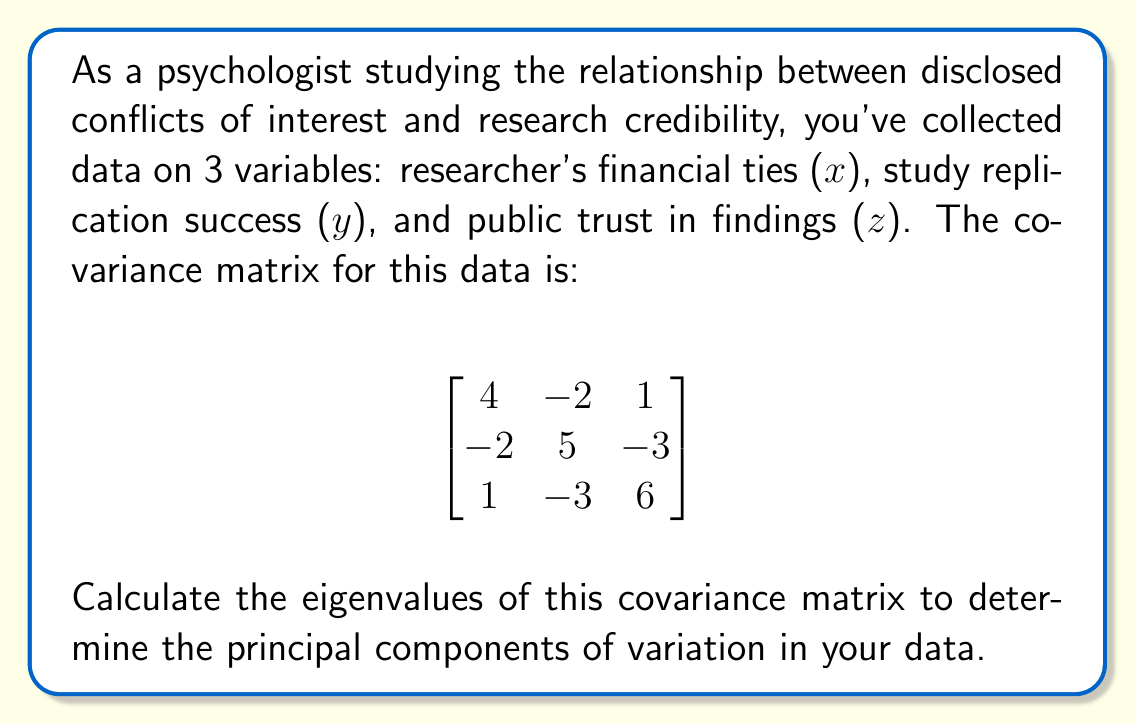Show me your answer to this math problem. To find the eigenvalues of the covariance matrix, we need to solve the characteristic equation:

$$\det(A - \lambda I) = 0$$

Where $A$ is our covariance matrix and $\lambda$ represents the eigenvalues.

1) First, let's set up the equation:

$$\det\begin{pmatrix}
4-\lambda & -2 & 1 \\
-2 & 5-\lambda & -3 \\
1 & -3 & 6-\lambda
\end{pmatrix} = 0$$

2) Expanding the determinant:

$$(4-\lambda)[(5-\lambda)(6-\lambda) - 9] + (-2)[(-2)(6-\lambda) - 1] + (1)[(-2)(-3) - (5-\lambda)] = 0$$

3) Simplifying:

$$(4-\lambda)(30-11\lambda+\lambda^2-9) + (-2)(-12+2\lambda-1) + (1)(6-5+\lambda) = 0$$
$$(4-\lambda)(21-11\lambda+\lambda^2) + (-2)(-13+2\lambda) + (1+\lambda) = 0$$

4) Expanding:

$$84-44\lambda+4\lambda^2-21\lambda+11\lambda^2-\lambda^3 + 26-4\lambda + 1 + \lambda = 0$$

5) Collecting like terms:

$$-\lambda^3 + 15\lambda^2 - 48\lambda + 111 = 0$$

6) This is our characteristic polynomial. To find the roots (eigenvalues), we can use the cubic formula or a numerical method. The roots are:

$$\lambda_1 \approx 9.38$$
$$\lambda_2 \approx 3.83$$
$$\lambda_3 \approx 1.79$$
Answer: The eigenvalues of the covariance matrix are approximately 9.38, 3.83, and 1.79. 